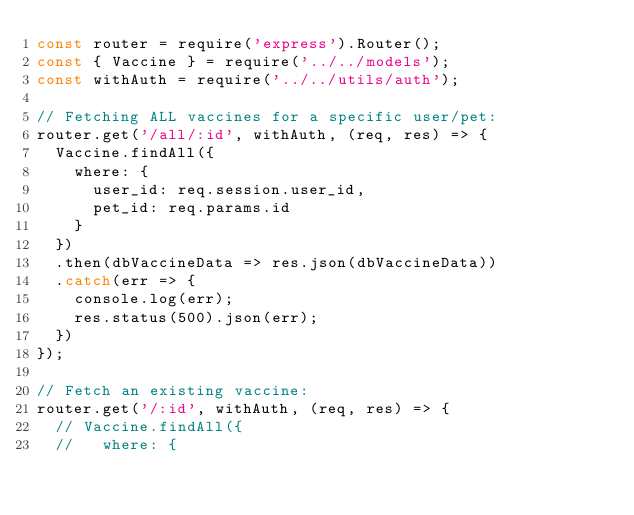Convert code to text. <code><loc_0><loc_0><loc_500><loc_500><_JavaScript_>const router = require('express').Router();
const { Vaccine } = require('../../models');
const withAuth = require('../../utils/auth');

// Fetching ALL vaccines for a specific user/pet:
router.get('/all/:id', withAuth, (req, res) => {
  Vaccine.findAll({
    where: {
      user_id: req.session.user_id,
      pet_id: req.params.id
    }
  })
  .then(dbVaccineData => res.json(dbVaccineData))
  .catch(err => {
    console.log(err);
    res.status(500).json(err);
  })
});

// Fetch an existing vaccine:
router.get('/:id', withAuth, (req, res) => {
  // Vaccine.findAll({
  //   where: {</code> 